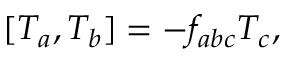<formula> <loc_0><loc_0><loc_500><loc_500>[ T _ { a } , T _ { b } ] = - f _ { a b c } T _ { c } ,</formula> 